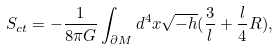Convert formula to latex. <formula><loc_0><loc_0><loc_500><loc_500>S _ { c t } = - \frac { 1 } { 8 \pi G } \int _ { \partial M } d ^ { 4 } x \sqrt { - h } ( \frac { 3 } { l } + \frac { l } { 4 } R ) ,</formula> 